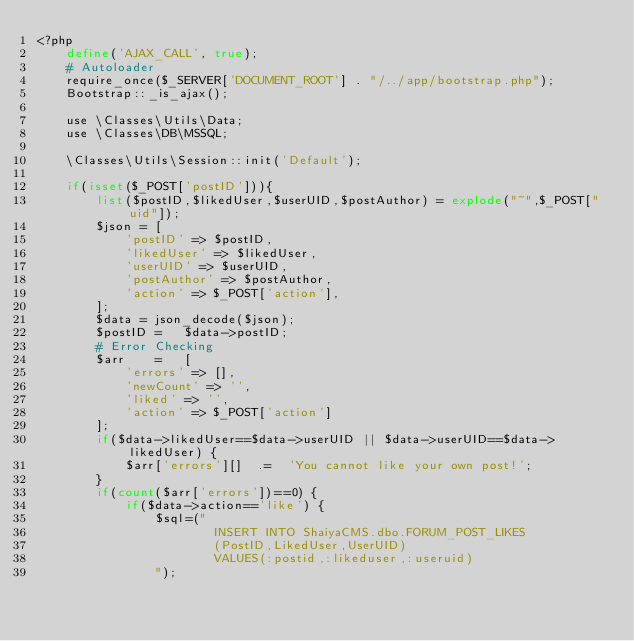Convert code to text. <code><loc_0><loc_0><loc_500><loc_500><_PHP_><?php
	define('AJAX_CALL', true);
	# Autoloader
	require_once($_SERVER['DOCUMENT_ROOT'] . "/../app/bootstrap.php");
	Bootstrap::_is_ajax();
	
	use \Classes\Utils\Data;
	use \Classes\DB\MSSQL;
	
	\Classes\Utils\Session::init('Default');
	
	if(isset($_POST['postID'])){
		list($postID,$likedUser,$userUID,$postAuthor) = explode("~",$_POST["uid"]);
		$json = [
			'postID' => $postID,
			'likedUser' => $likedUser,
			'userUID' => $userUID,
			'postAuthor' => $postAuthor,
			'action' => $_POST['action'],
		];
		$data = json_decode($json);
		$postID	=	$data->postID;
		# Error Checking
		$arr	=	[
			'errors' => [],
			'newCount' => '',
			'liked' => '',
			'action' => $_POST['action']
		];
		if($data->likedUser==$data->userUID || $data->userUID==$data->likedUser) {
			$arr['errors'][]  .=  'You cannot like your own post!';
		}
		if(count($arr['errors'])==0) {
			if($data->action=='like') {
				$sql=("
						INSERT INTO ShaiyaCMS.dbo.FORUM_POST_LIKES
						(PostID,LikedUser,UserUID)
						VALUES(:postid,:likeduser,:useruid)
				");</code> 